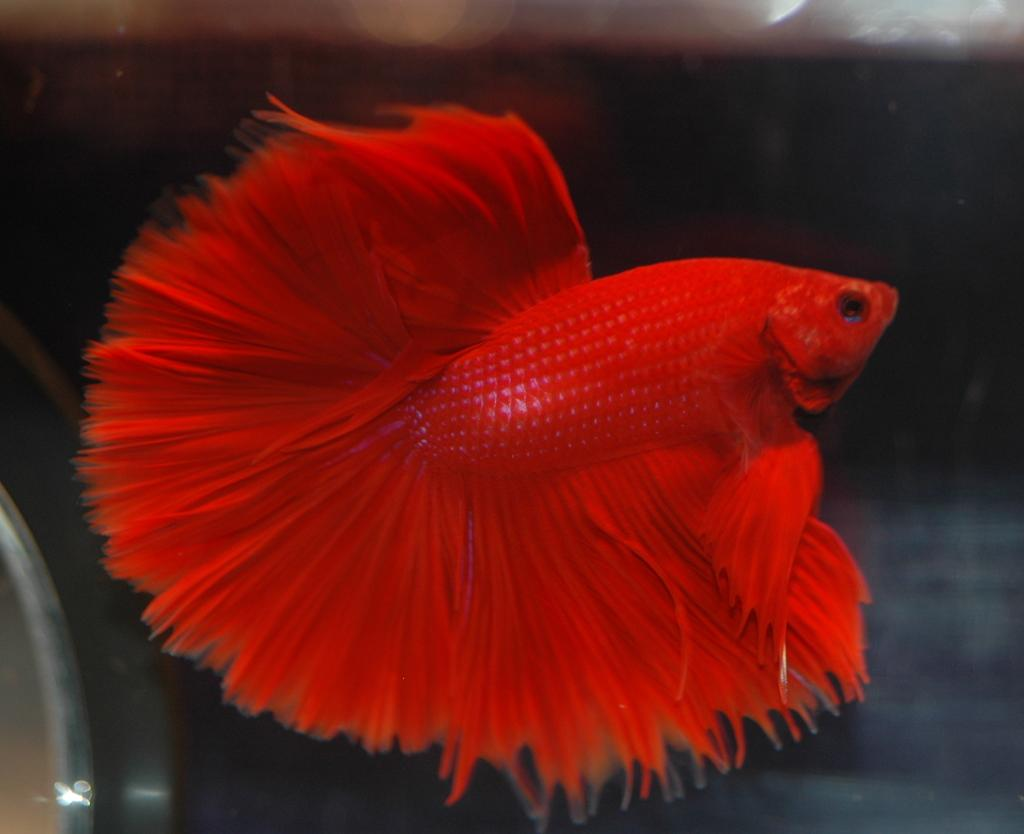What type of animal is in the image? There is a fighter fish in the image. What type of plant is growing near the fighter fish in the image? There is no plant present in the image; it only features a fighter fish. 